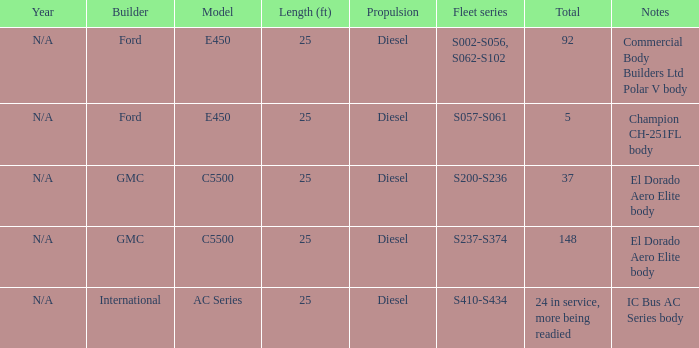Which builder has a fleet series of s057-s061? Ford. 